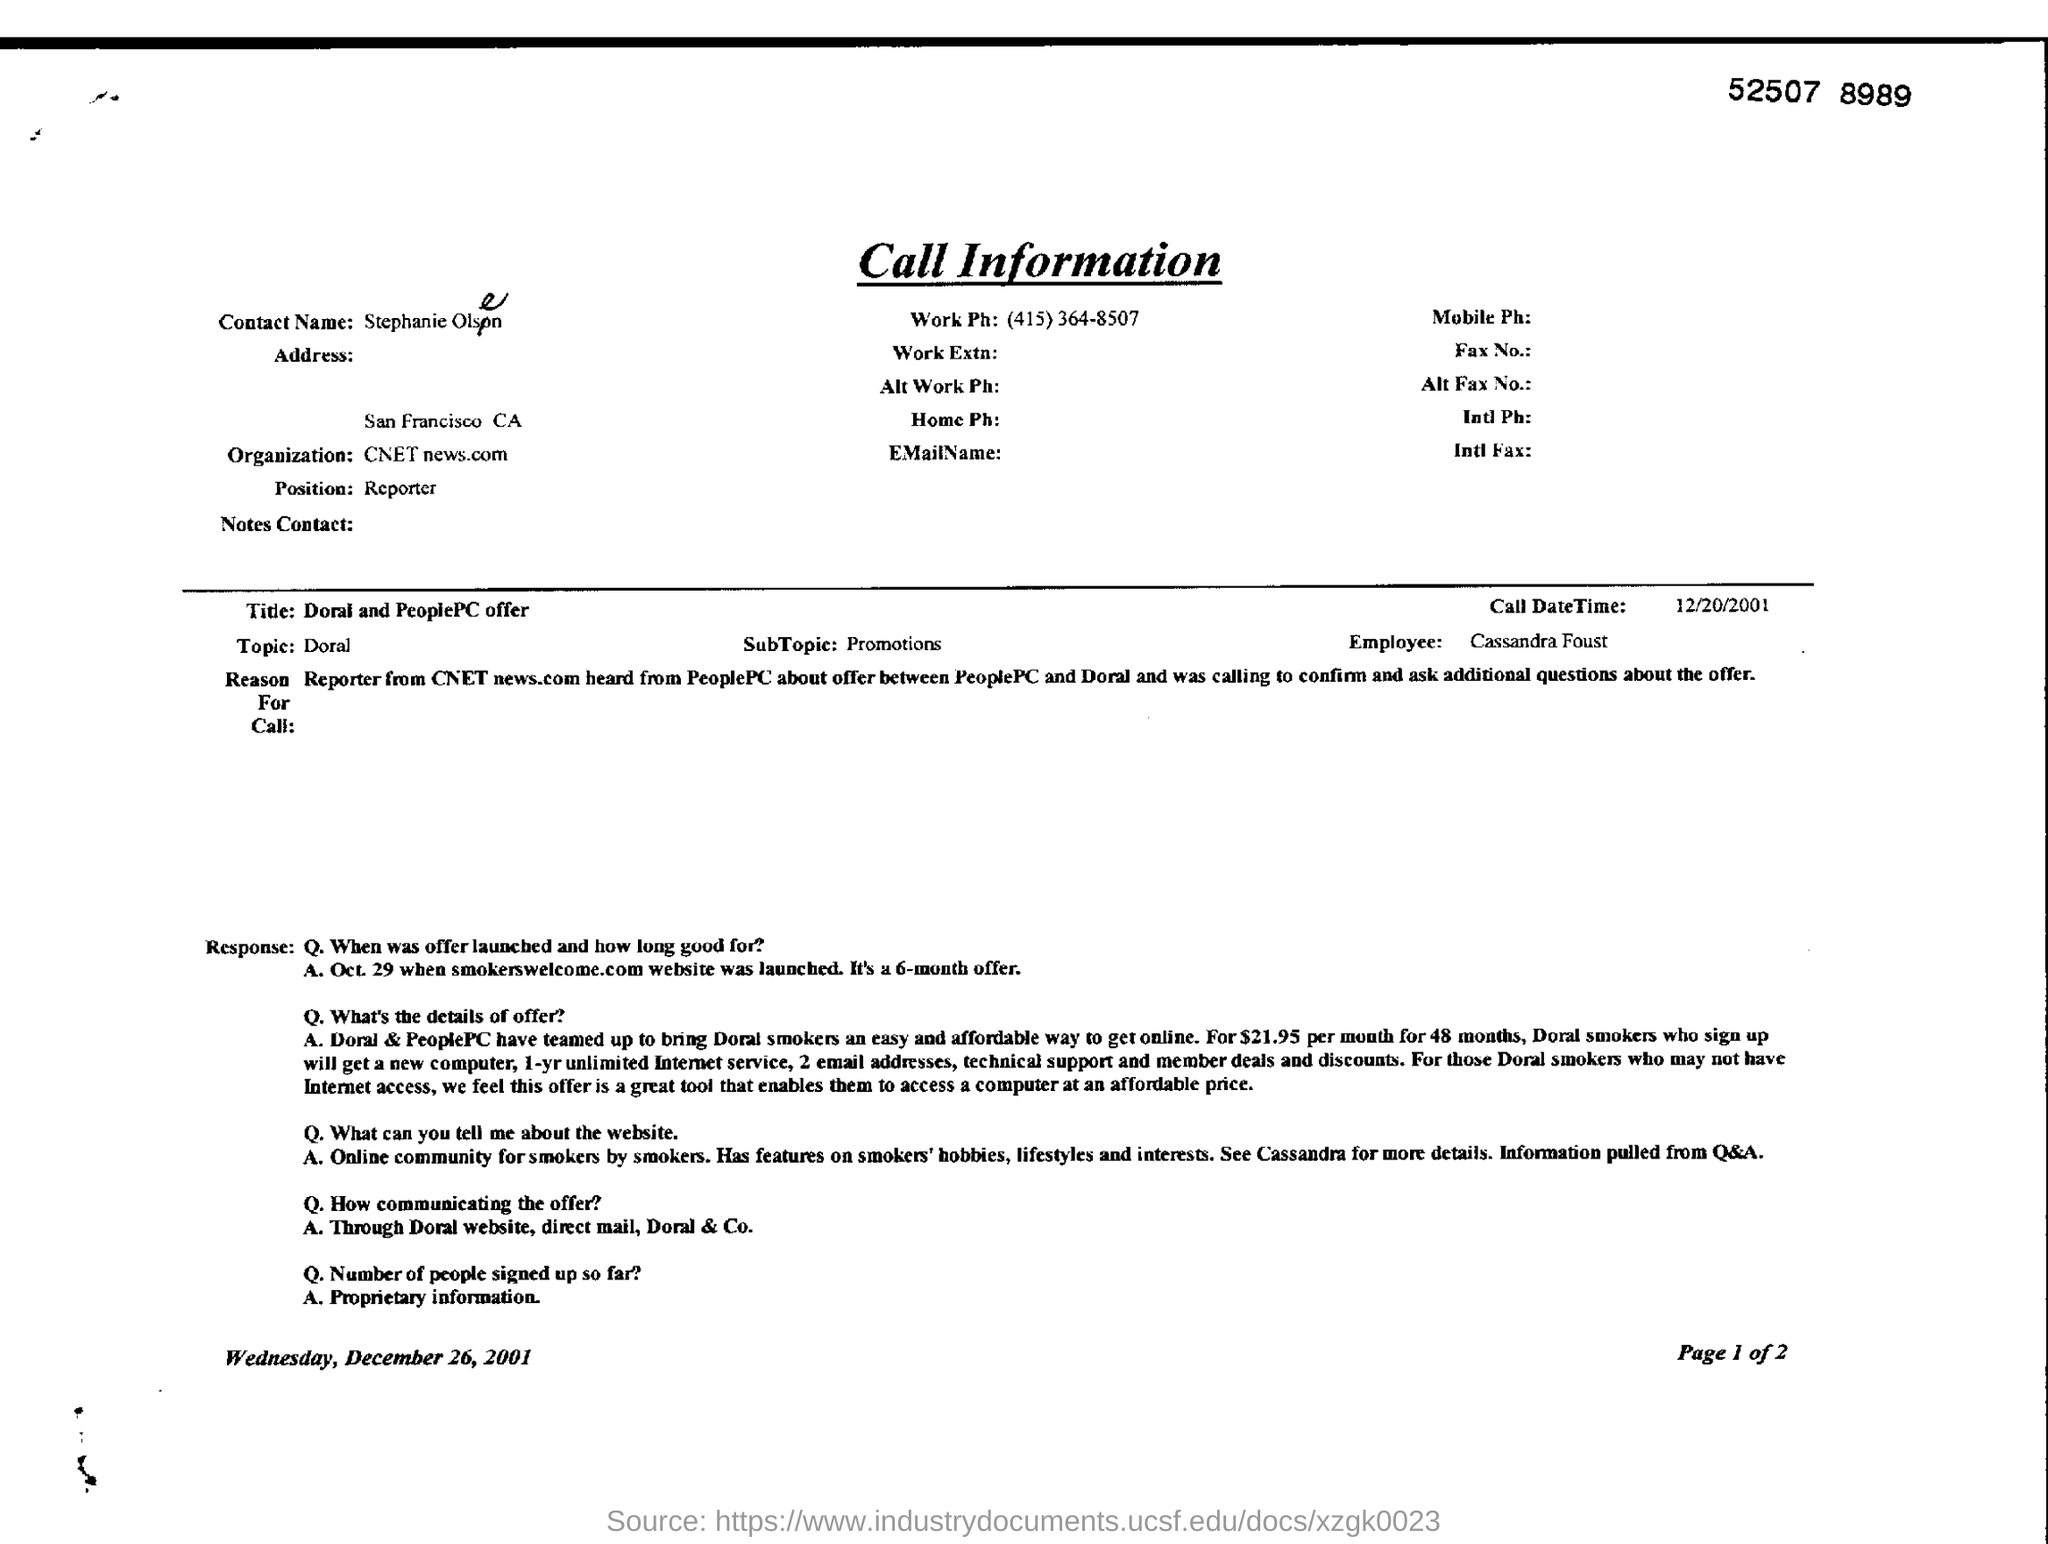What is the Contact Name?
Keep it short and to the point. Stephanie Olsen. What is the Position?
Your response must be concise. Reporter. What is the Organization?
Ensure brevity in your answer.  CNET news.com. What is the Title?
Your answer should be compact. Doral and PeoplePC offer. What is the Topic?
Your answer should be very brief. Doral. What is the SubTopic?
Make the answer very short. Promotions. Who is the Employee?
Offer a very short reply. Cassandra Foust. 